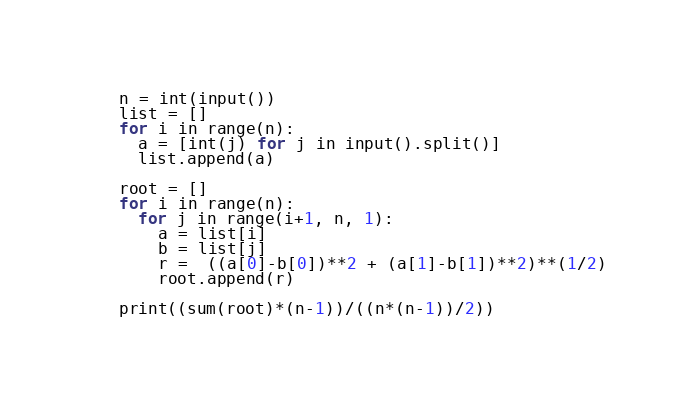Convert code to text. <code><loc_0><loc_0><loc_500><loc_500><_Python_>n = int(input())
list = []
for i in range(n):
  a = [int(j) for j in input().split()]
  list.append(a)
  
root = []
for i in range(n):
  for j in range(i+1, n, 1):
    a = list[i]
    b = list[j]
    r =  ((a[0]-b[0])**2 + (a[1]-b[1])**2)**(1/2)
    root.append(r)
    
print((sum(root)*(n-1))/((n*(n-1))/2))</code> 